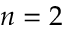Convert formula to latex. <formula><loc_0><loc_0><loc_500><loc_500>n = 2</formula> 